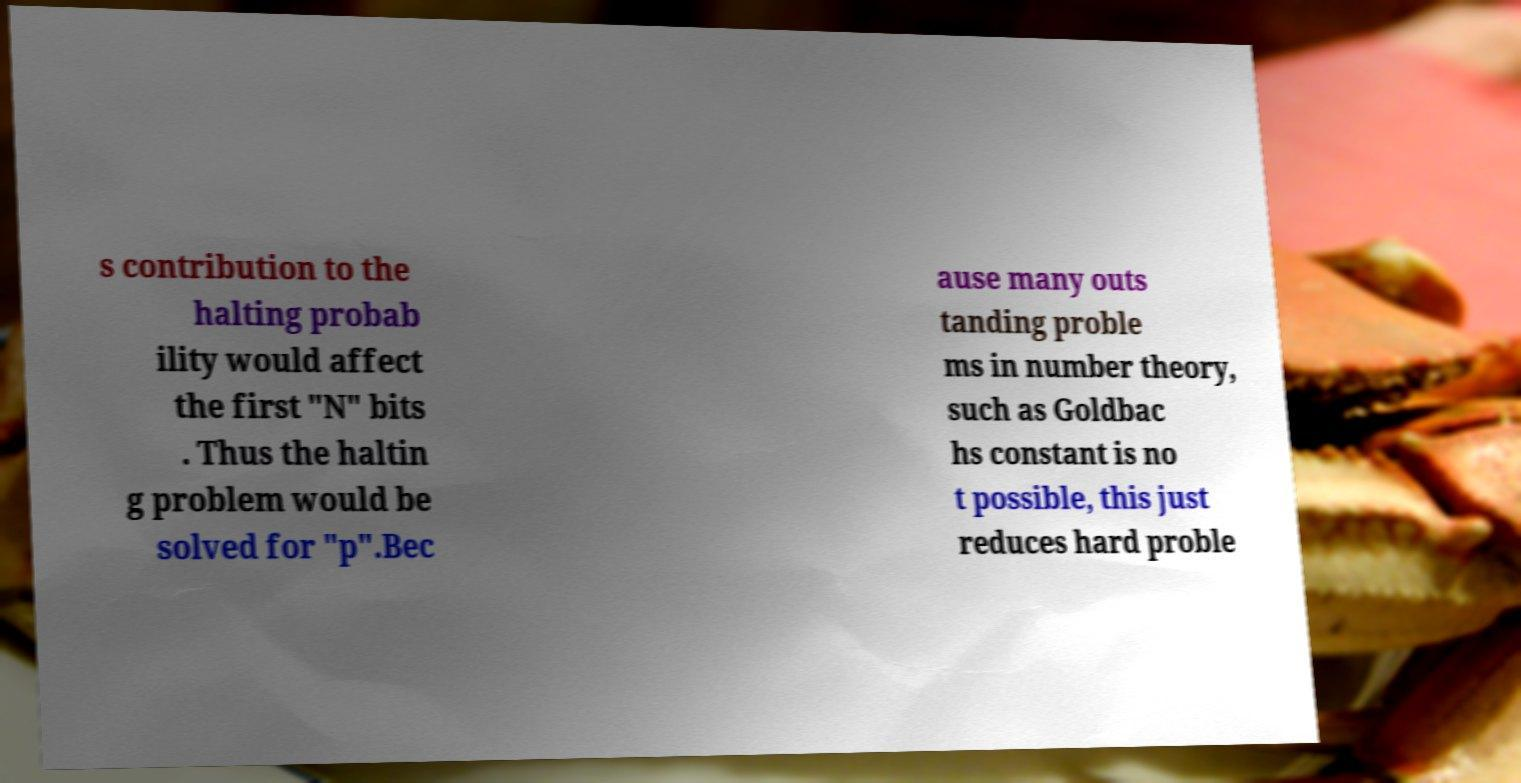Can you read and provide the text displayed in the image?This photo seems to have some interesting text. Can you extract and type it out for me? s contribution to the halting probab ility would affect the first "N" bits . Thus the haltin g problem would be solved for "p".Bec ause many outs tanding proble ms in number theory, such as Goldbac hs constant is no t possible, this just reduces hard proble 